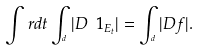Convert formula to latex. <formula><loc_0><loc_0><loc_500><loc_500>\int _ { \real } \ r d t \int _ { \real ^ { d } } | D \ 1 _ { E _ { t } } | = \int _ { \real ^ { d } } | D f | .</formula> 